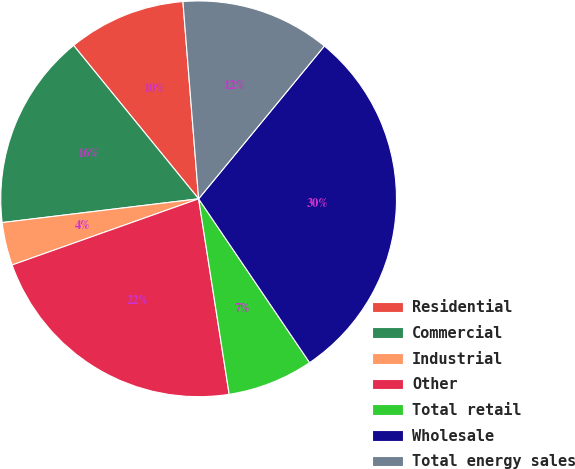Convert chart to OTSL. <chart><loc_0><loc_0><loc_500><loc_500><pie_chart><fcel>Residential<fcel>Commercial<fcel>Industrial<fcel>Other<fcel>Total retail<fcel>Wholesale<fcel>Total energy sales<nl><fcel>9.62%<fcel>16.03%<fcel>3.51%<fcel>22.04%<fcel>7.01%<fcel>29.56%<fcel>12.22%<nl></chart> 